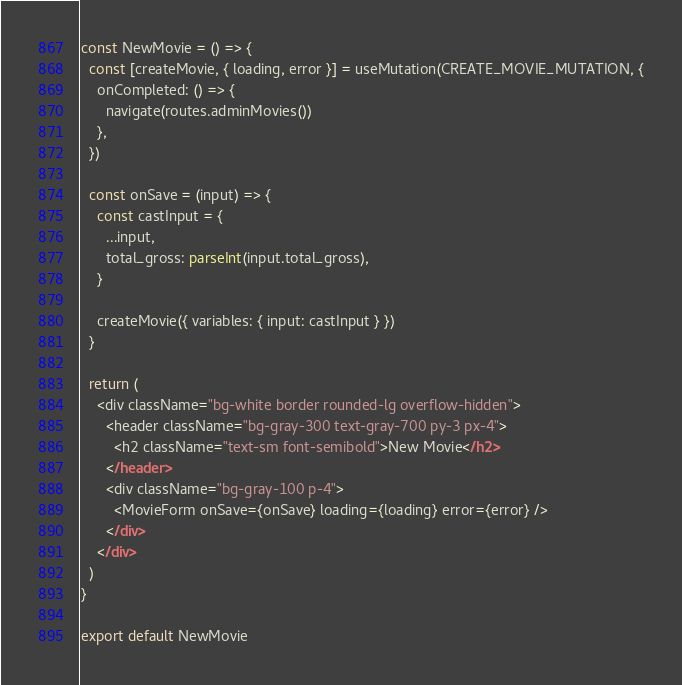Convert code to text. <code><loc_0><loc_0><loc_500><loc_500><_JavaScript_>const NewMovie = () => {
  const [createMovie, { loading, error }] = useMutation(CREATE_MOVIE_MUTATION, {
    onCompleted: () => {
      navigate(routes.adminMovies())
    },
  })

  const onSave = (input) => {
    const castInput = {
      ...input,
      total_gross: parseInt(input.total_gross),
    }

    createMovie({ variables: { input: castInput } })
  }

  return (
    <div className="bg-white border rounded-lg overflow-hidden">
      <header className="bg-gray-300 text-gray-700 py-3 px-4">
        <h2 className="text-sm font-semibold">New Movie</h2>
      </header>
      <div className="bg-gray-100 p-4">
        <MovieForm onSave={onSave} loading={loading} error={error} />
      </div>
    </div>
  )
}

export default NewMovie
</code> 